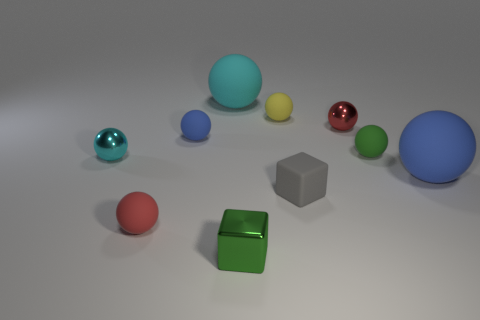There is a large matte ball that is in front of the large object that is behind the tiny cyan metal ball; what is its color?
Keep it short and to the point. Blue. Is there a metallic object of the same size as the cyan rubber thing?
Your answer should be very brief. No. There is a tiny green thing that is behind the small red matte ball that is in front of the big thing that is behind the large blue thing; what is it made of?
Give a very brief answer. Rubber. There is a blue sphere that is to the left of the small green shiny cube; how many big cyan spheres are on the left side of it?
Keep it short and to the point. 0. Do the green thing that is to the left of the green rubber object and the red shiny thing have the same size?
Give a very brief answer. Yes. What number of large things have the same shape as the small cyan object?
Your response must be concise. 2. What is the shape of the small gray object?
Provide a succinct answer. Cube. Are there the same number of large blue objects left of the red matte sphere and tiny things?
Your answer should be compact. No. Is there anything else that has the same material as the yellow object?
Your answer should be compact. Yes. Is the green ball that is right of the yellow object made of the same material as the small blue ball?
Ensure brevity in your answer.  Yes. 